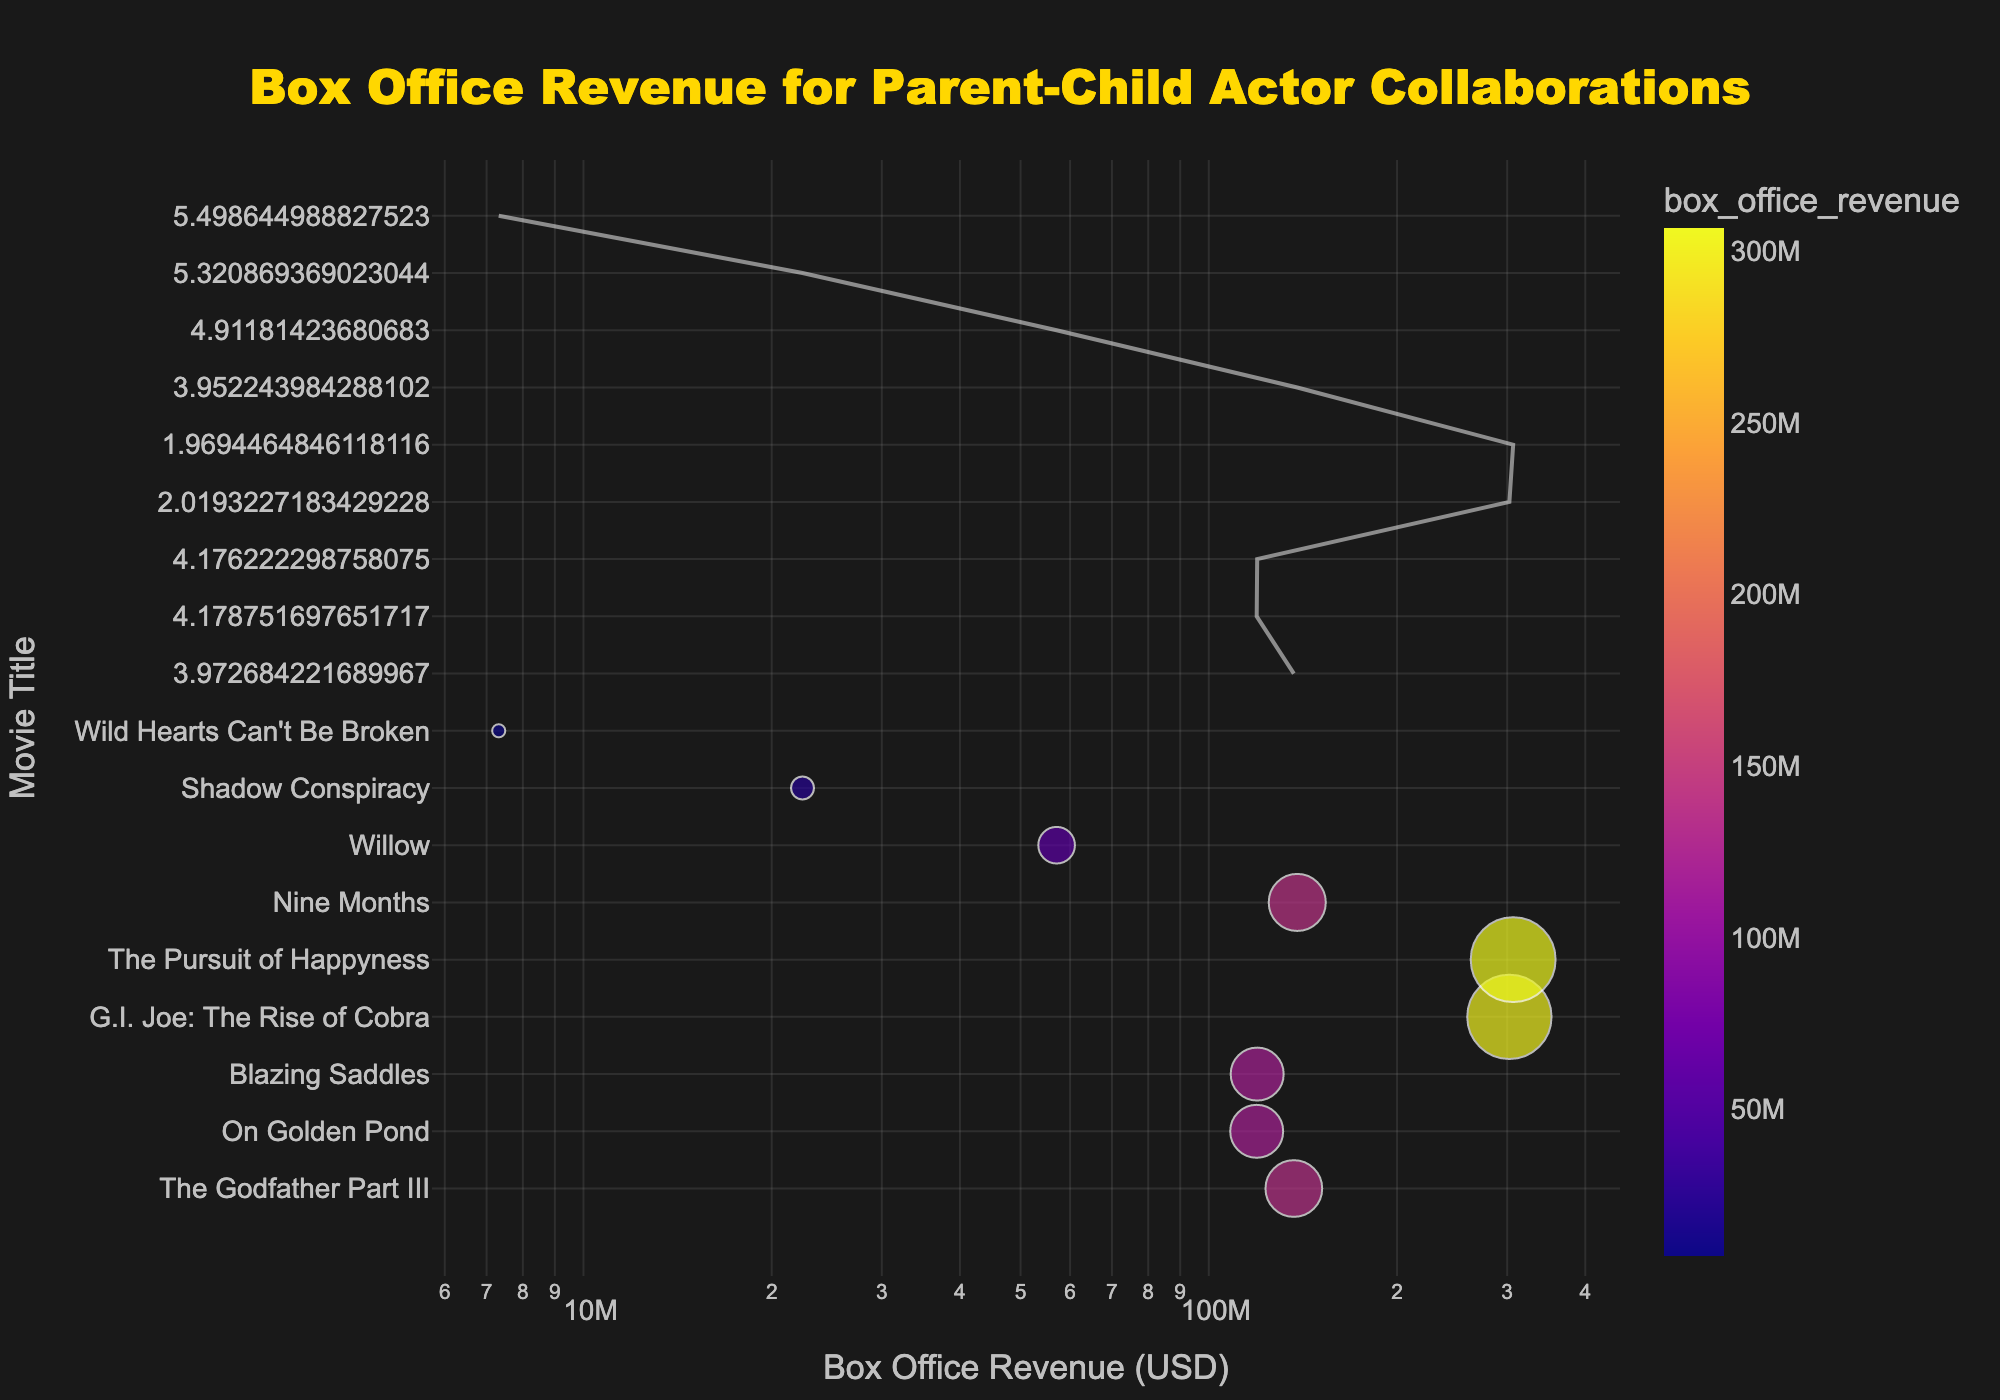what’s the title of the figure? The title is located at the top center of the figure and is written in large, bold font.
Answer: Box Office Revenue for Parent-Child Actor Collaborations How many movies have box office revenues above 100 million USD? To find this, look at the x-axis values and count the number of points whose x-values are greater than 100 million.
Answer: 5 Which movie had the lowest box office revenue? The movie with the lowest x-axis value represents the lowest box office revenue.
Answer: Wild Hearts Can't Be Broken Which movie has the highest box office revenue and what are the parent-child actors? Identify the rightmost point on the x-axis representing the highest revenue, then check its hover text for details.
Answer: G.I. Joe: The Rise of Cobra, Stephen Sommers, Joe Marlon Wayans What trend does the trend line indicate about box office revenue over time? The trend line provides a visual indication of the overall direction of box office revenues. Assess its slope.
Answer: Increasing How does the box office revenue of "On Golden Pond" compare to "Nine Months"? Find both points on the scatter plot, referencing the x-axis values, and compare their box office revenues.
Answer: "Nine Months" had higher revenue What is the average box office revenue of the movies listed? Sum up all the box office revenues and then divide by the number of movies.
Answer: 147.5 million USD Is there a noticeable correlation between parent-child actor collaborations and box office revenue? Observe the scatter plot and consider the trend line to determine if there's a meaningful pattern indicating a relationship.
Answer: Yes, somewhat positive What color scheme is used in the scatter plot? Analyze the gradient of colors in the plot, which gives an idea of the scale applied.
Answer: Sequential Plasma What can be inferred from the size of the data points? The size of the points corresponds to the amount of box office revenue, larger points signify higher revenues.
Answer: Larger points indicate higher revenue 